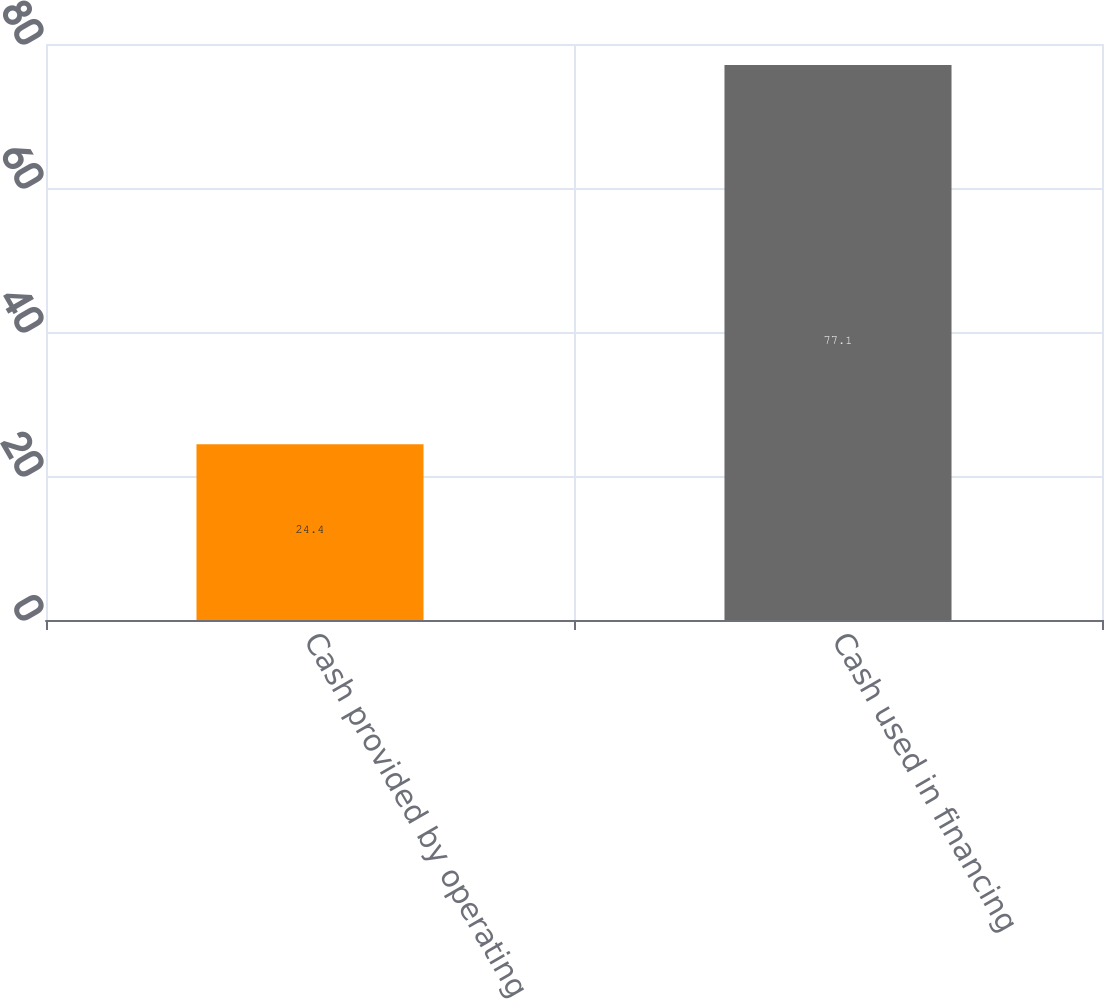<chart> <loc_0><loc_0><loc_500><loc_500><bar_chart><fcel>Cash provided by operating<fcel>Cash used in financing<nl><fcel>24.4<fcel>77.1<nl></chart> 